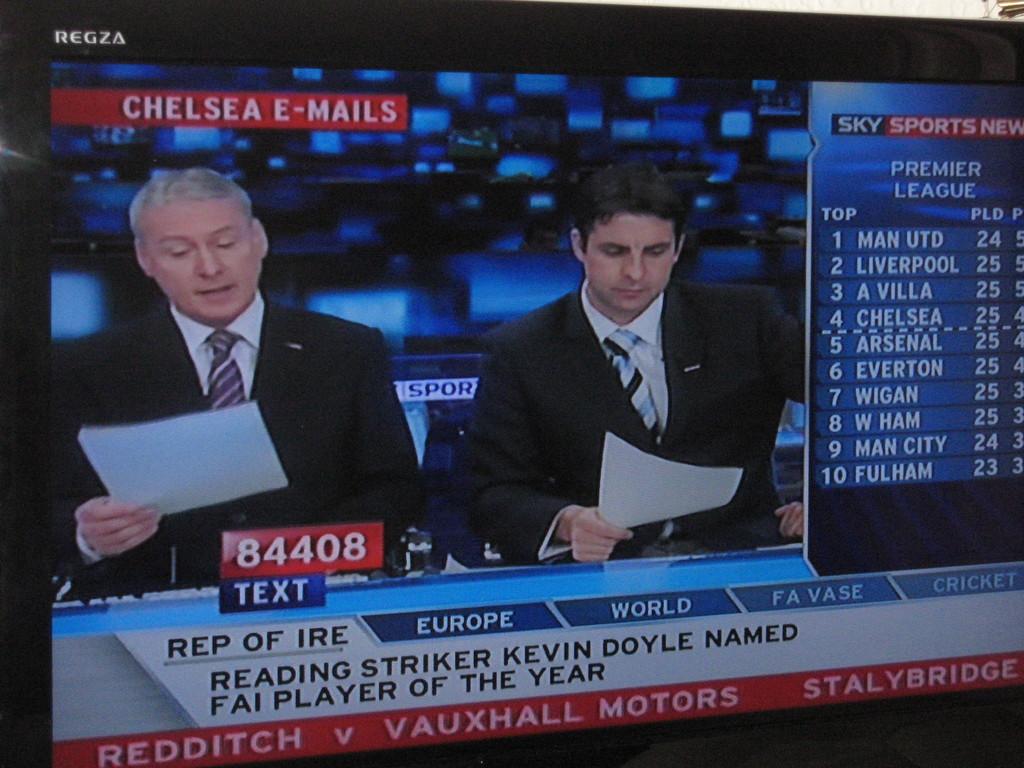Who is ranked number two on the sky sports chart?
Provide a succinct answer. Liverpool. What number would you use to text them?
Your answer should be very brief. 84408. 